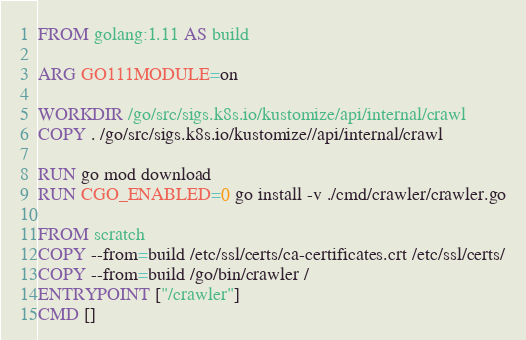<code> <loc_0><loc_0><loc_500><loc_500><_Dockerfile_>FROM golang:1.11 AS build

ARG GO111MODULE=on

WORKDIR /go/src/sigs.k8s.io/kustomize/api/internal/crawl
COPY . /go/src/sigs.k8s.io/kustomize//api/internal/crawl

RUN go mod download
RUN CGO_ENABLED=0 go install -v ./cmd/crawler/crawler.go

FROM scratch
COPY --from=build /etc/ssl/certs/ca-certificates.crt /etc/ssl/certs/
COPY --from=build /go/bin/crawler /
ENTRYPOINT ["/crawler"]
CMD []
</code> 